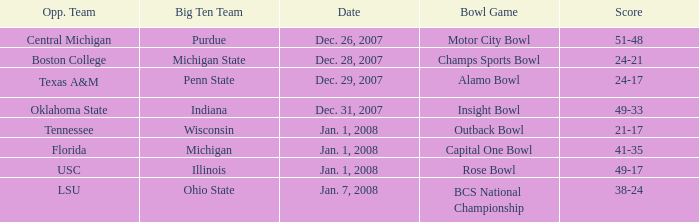What was the score of the BCS National Championship game? 38-24. 